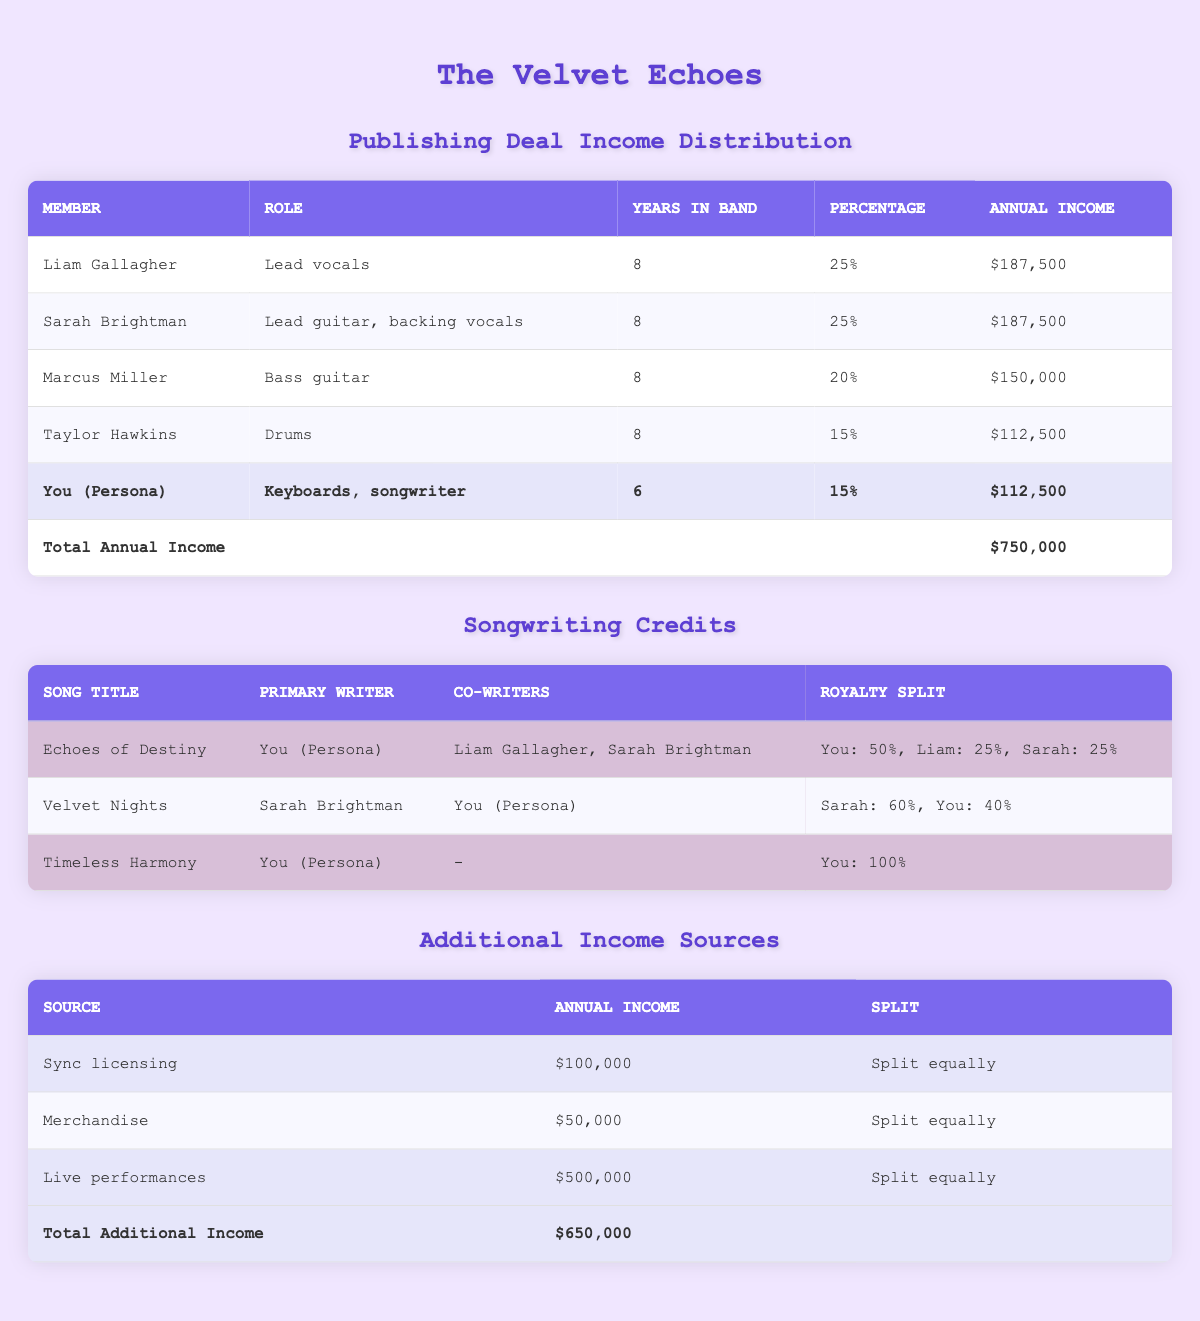What is the total annual income for The Velvet Echoes? The total annual income is listed in the table's footer. It shows that the total annual income is $750,000.
Answer: $750,000 Who is the highest earning member of the band? By looking at the annual income of each band member, Liam Gallagher and Sarah Brightman each earn $187,500, which is higher than the others. Therefore, there are two highest earners.
Answer: Liam Gallagher and Sarah Brightman What percentage of income does Marcus Miller receive? The table lists Marcus Miller's percentage of income as 20%.
Answer: 20% How much do all band members earn from additional income sources combined? The additional income sources listed total $650,000. This is calculated by adding $100,000 from sync licensing, $50,000 from merchandise, and $500,000 from live performances.
Answer: $650,000 Is Sarah Brightman the primary writer for "Echoes of Destiny"? The table shows that You (Persona) is the primary writer for "Echoes of Destiny," not Sarah Brightman.
Answer: No What is the average annual income of all band members? To find the average, add the incomes: $187,500 (Liam) + $187,500 (Sarah) + $150,000 (Marcus) + $112,500 (Taylor) + $112,500 (You) = $750,000. Divide by 5 members: $750,000 / 5 = $150,000.
Answer: $150,000 How much percentage of the total income does Taylor Hawkins receive? Taylor Hawkins earns 15% of the total income, as stated in the income distribution section.
Answer: 15% Which song features You (Persona) as the primary writer and has no co-writers? The song "Timeless Harmony" has You (Persona) as the primary writer with no co-writers.
Answer: Timeless Harmony What is the total annual income earned by the band from live performances? The table indicates that live performances contribute to an annual income of $500,000.
Answer: $500,000 